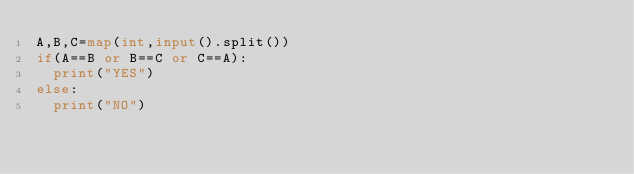Convert code to text. <code><loc_0><loc_0><loc_500><loc_500><_Python_>A,B,C=map(int,input().split())
if(A==B or B==C or C==A):
  print("YES")
else:
  print("NO")</code> 